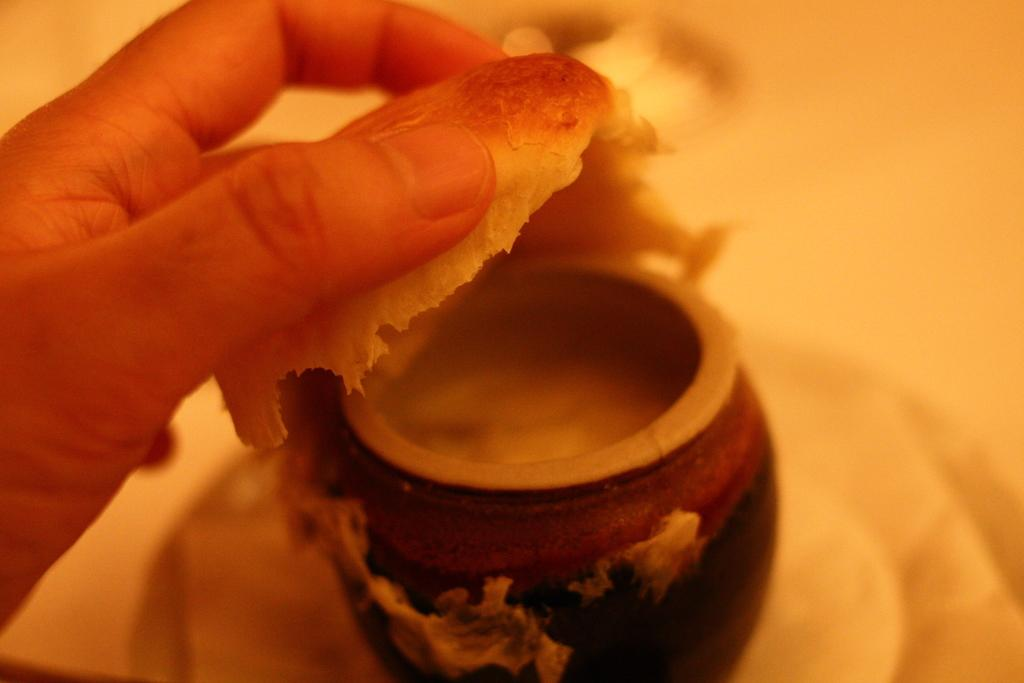What part of the human body is visible in the image? There is a human hand in the image. What object is present alongside the hand? There is a small pot in the image. What type of honey is being used to seal the stamp in the image? There is no honey or stamp present in the image; it only features a human hand and a small pot. 